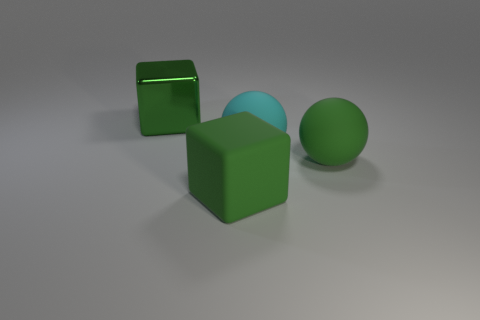There is a thing that is to the left of the large cyan matte ball and in front of the large metal object; what is its color?
Keep it short and to the point. Green. Does the green rubber sphere have the same size as the green block that is in front of the large cyan rubber object?
Make the answer very short. Yes. There is a big thing that is left of the matte cube; what is its shape?
Give a very brief answer. Cube. Is there anything else that is the same material as the big cyan object?
Make the answer very short. Yes. Is the number of green blocks that are to the left of the green metallic block greater than the number of green matte things?
Provide a short and direct response. No. What number of green shiny blocks are to the right of the big green rubber cube that is in front of the green thing behind the cyan matte ball?
Offer a very short reply. 0. There is a green rubber object behind the big rubber block; is it the same size as the thing behind the big cyan matte ball?
Provide a short and direct response. Yes. What material is the big block behind the rubber block that is in front of the large cyan ball?
Give a very brief answer. Metal. How many objects are either large things on the right side of the big cyan object or large blue metallic blocks?
Your answer should be very brief. 1. Is the number of large green balls behind the cyan ball the same as the number of green rubber cubes behind the big metallic object?
Provide a succinct answer. Yes. 